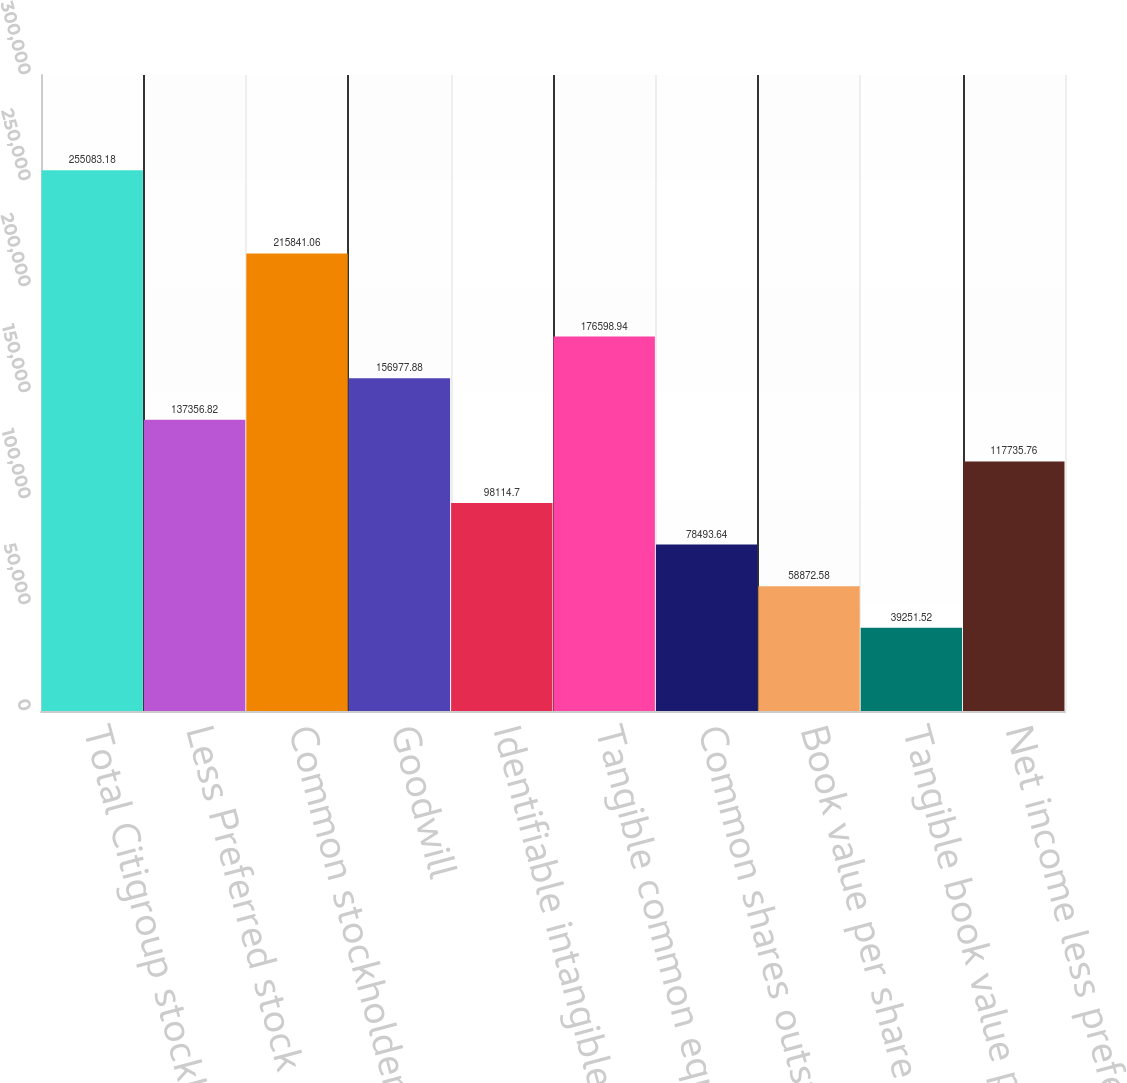Convert chart to OTSL. <chart><loc_0><loc_0><loc_500><loc_500><bar_chart><fcel>Total Citigroup stockholders'<fcel>Less Preferred stock<fcel>Common stockholders' equity<fcel>Goodwill<fcel>Identifiable intangible assets<fcel>Tangible common equity (TCE)<fcel>Common shares outstanding<fcel>Book value per share (common<fcel>Tangible book value per share<fcel>Net income less preferred<nl><fcel>255083<fcel>137357<fcel>215841<fcel>156978<fcel>98114.7<fcel>176599<fcel>78493.6<fcel>58872.6<fcel>39251.5<fcel>117736<nl></chart> 